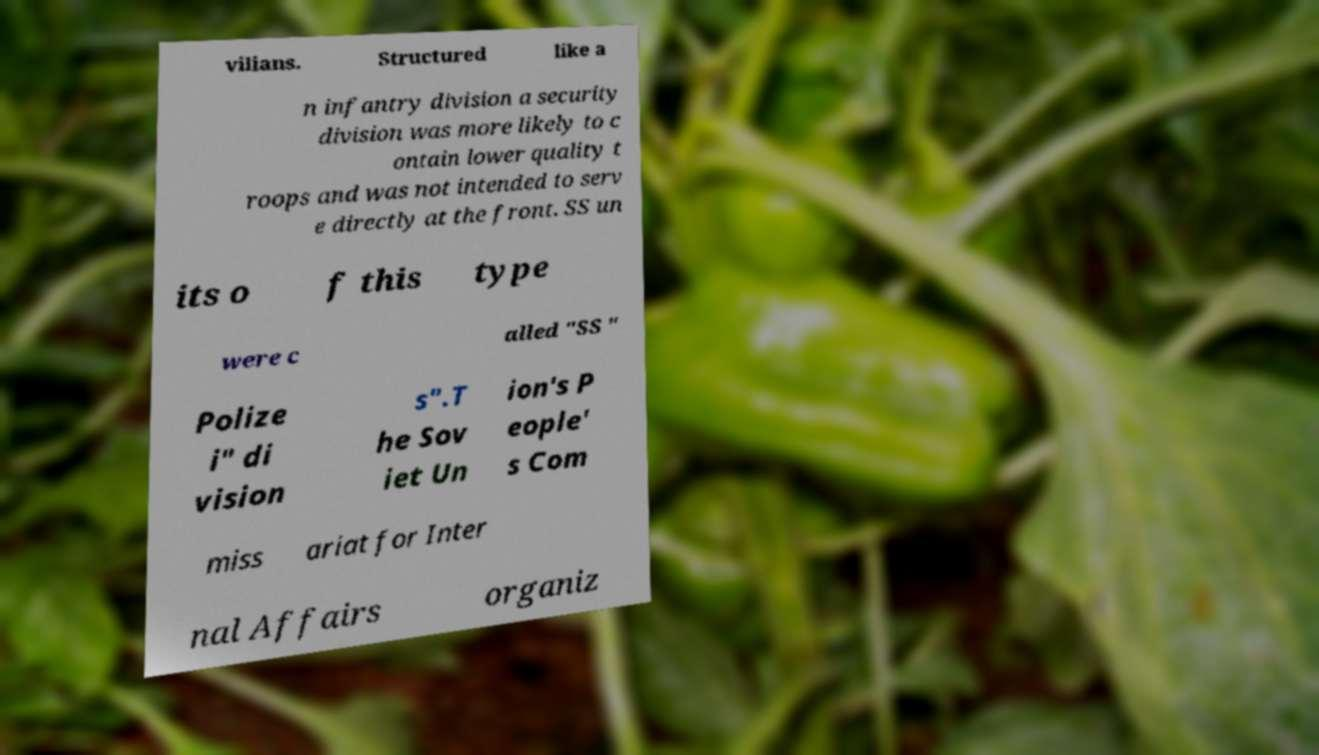Could you extract and type out the text from this image? vilians. Structured like a n infantry division a security division was more likely to c ontain lower quality t roops and was not intended to serv e directly at the front. SS un its o f this type were c alled "SS " Polize i" di vision s".T he Sov iet Un ion's P eople' s Com miss ariat for Inter nal Affairs organiz 